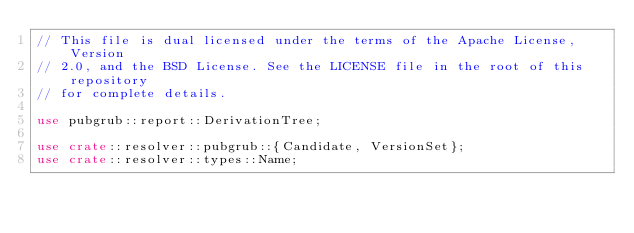Convert code to text. <code><loc_0><loc_0><loc_500><loc_500><_Rust_>// This file is dual licensed under the terms of the Apache License, Version
// 2.0, and the BSD License. See the LICENSE file in the root of this repository
// for complete details.

use pubgrub::report::DerivationTree;

use crate::resolver::pubgrub::{Candidate, VersionSet};
use crate::resolver::types::Name;
</code> 